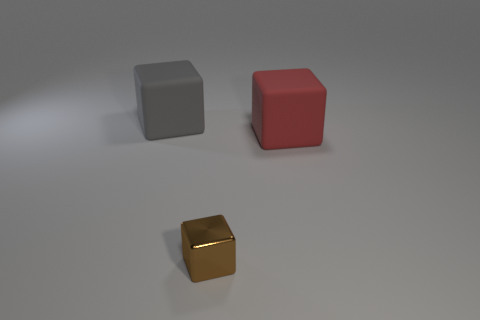Add 2 gray blocks. How many objects exist? 5 Add 2 tiny brown metallic things. How many tiny brown metallic things exist? 3 Subtract 1 red cubes. How many objects are left? 2 Subtract all brown metallic cylinders. Subtract all gray matte objects. How many objects are left? 2 Add 1 large gray blocks. How many large gray blocks are left? 2 